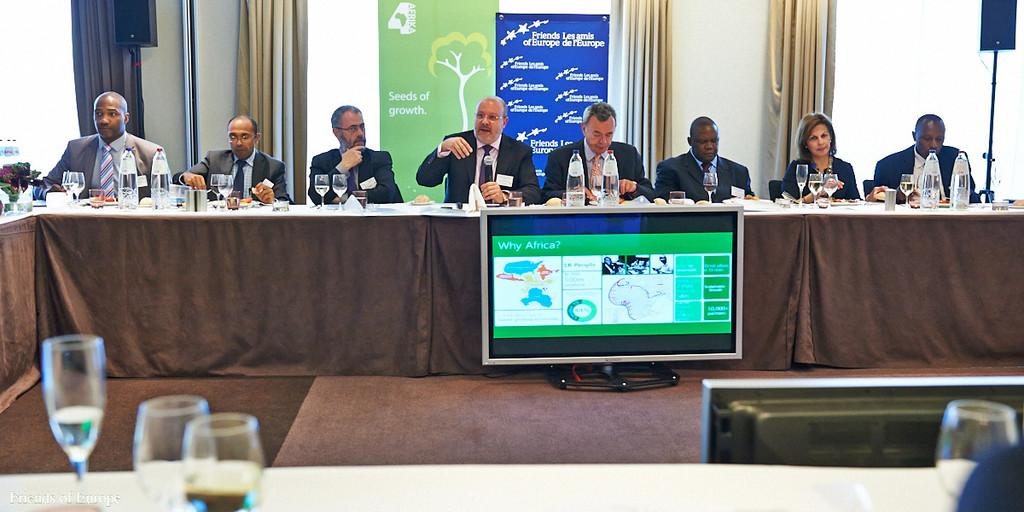<image>
Relay a brief, clear account of the picture shown. Man speaking in front of a monitor which says "Why Africa?" 